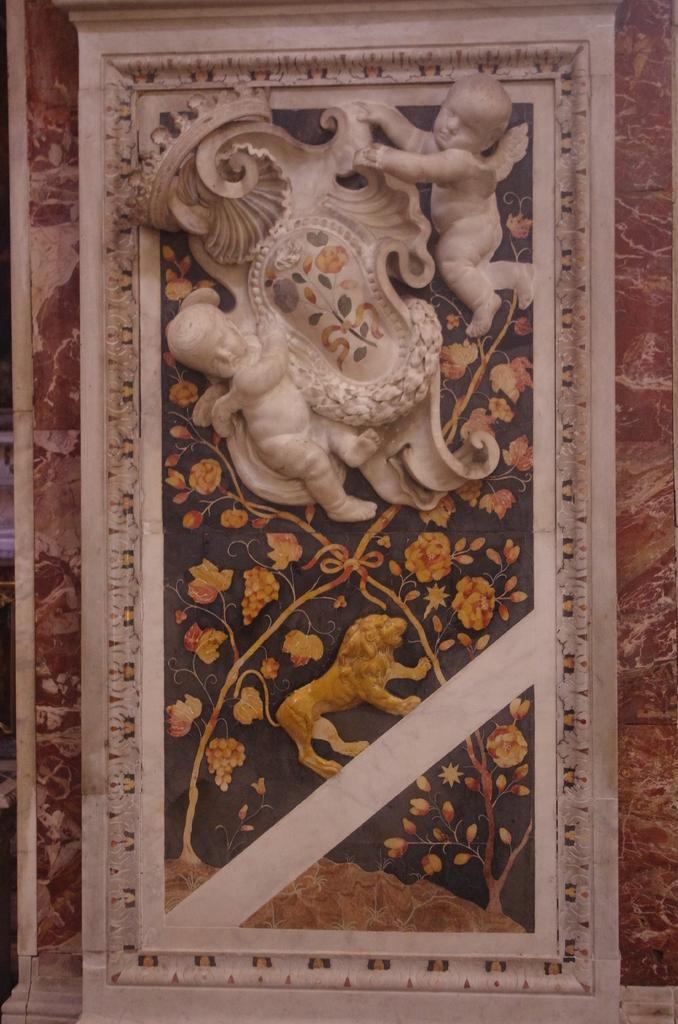What is the main subject of the image? The main subject of the image is a sculpture on the wall. Can you see any trails leading to the lake in the image? There is no lake or trail present in the image; it only features a sculpture on the wall. What color is the wrist of the person holding the sculpture in the image? There is no person holding the sculpture in the image, as it is mounted on the wall. 